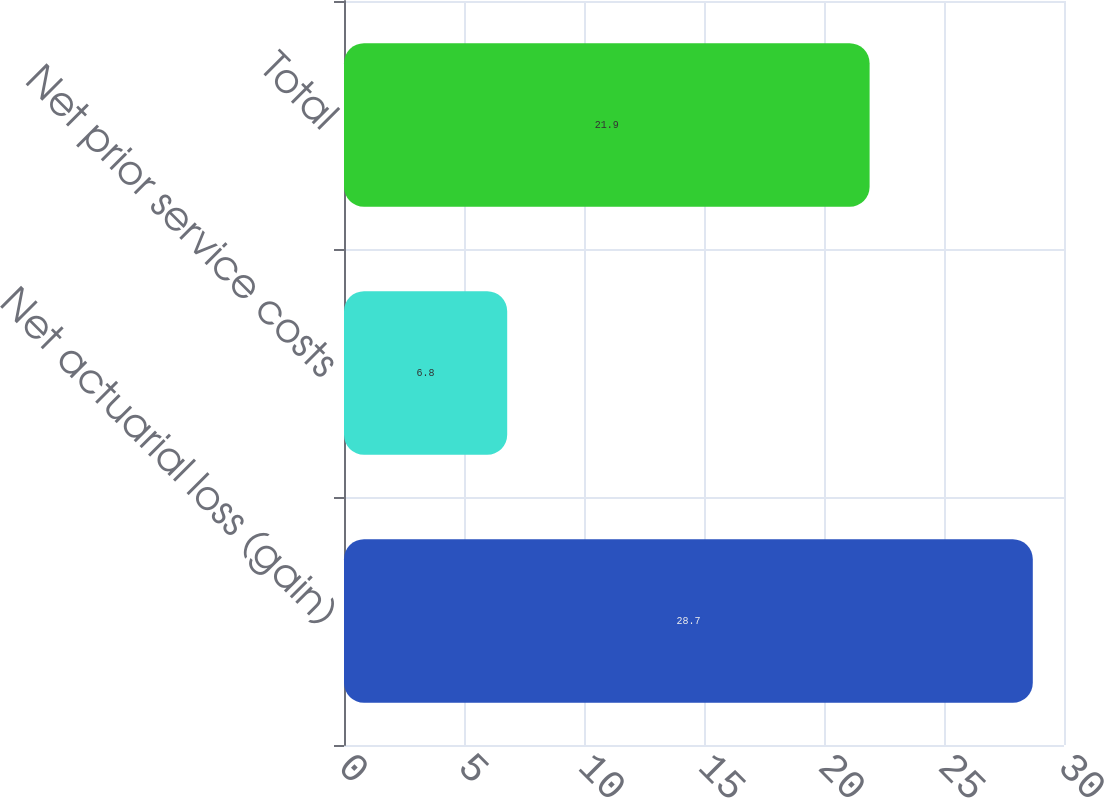Convert chart. <chart><loc_0><loc_0><loc_500><loc_500><bar_chart><fcel>Net actuarial loss (gain)<fcel>Net prior service costs<fcel>Total<nl><fcel>28.7<fcel>6.8<fcel>21.9<nl></chart> 